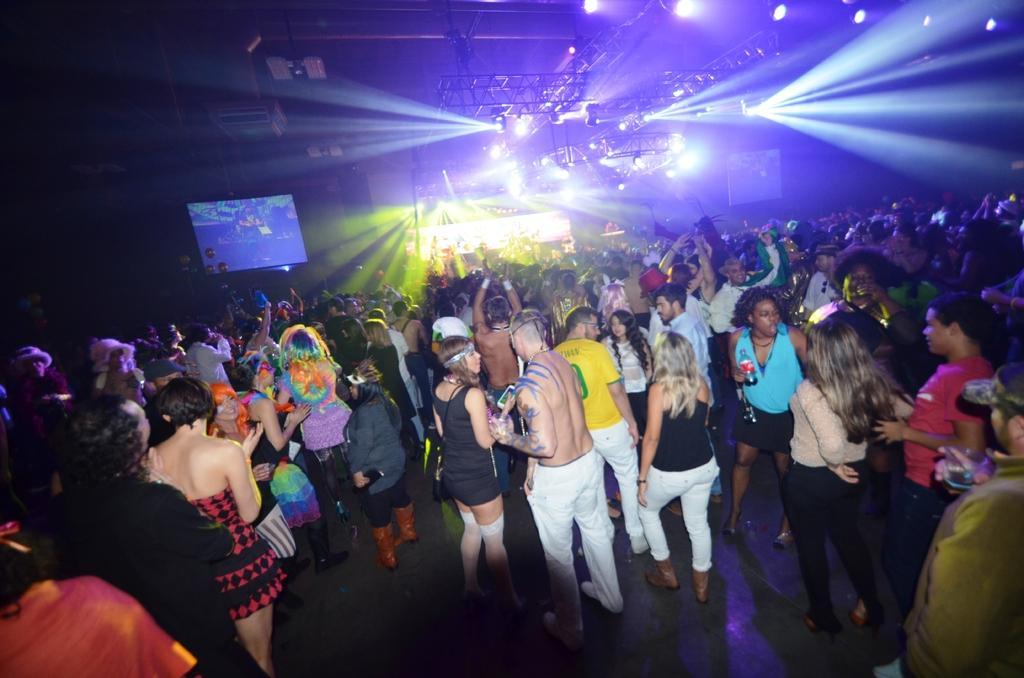How would you summarize this image in a sentence or two? This is the picture of a place where we have some people, among them some are lifting their hands and around there are some screens and some lights on the roof. 